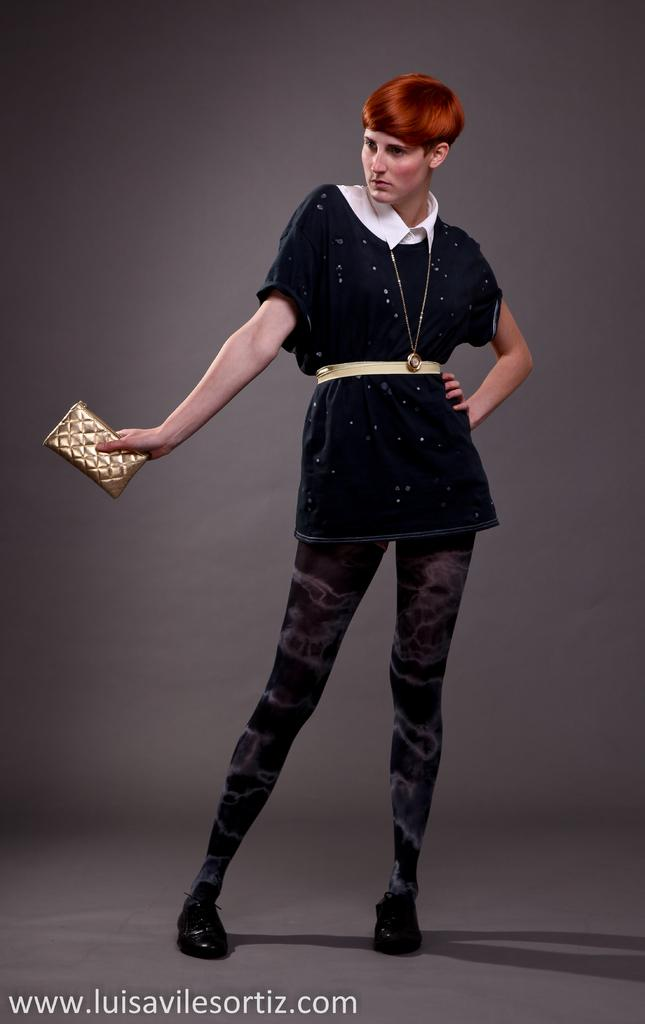Who is present in the image? There is a woman in the image. What is the woman wearing? The woman is wearing a black dress. What object is the woman holding? The woman is holding a purse. What type of surface is visible in the image? There is a floor visible in the image. What can be seen in the background of the image? There is a wall in the background of the image. Reasoning: Let' Let's think step by step in order to produce the conversation. We start by identifying the main subject in the image, which is the woman. Then, we describe her clothing and the object she is holding. Next, we mention the floor, which is a part of the setting. Finally, we include the wall in the background to provide more context about the environment. Absurd Question/Answer: Is there a beggar standing next to the volcano in the image? There is no beggar or volcano present in the image. What is the woman's desire in the image? There is no information about the woman's desires in the image. 